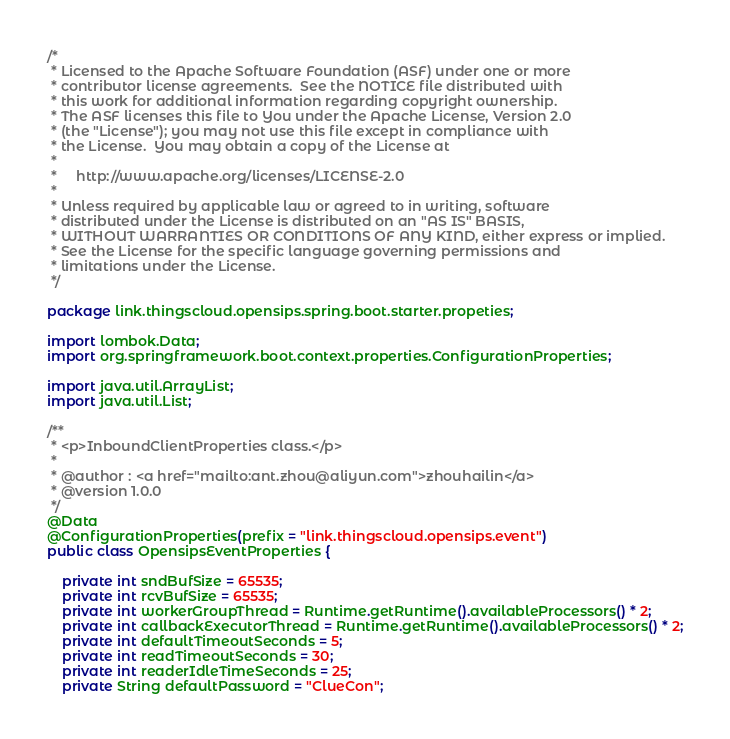Convert code to text. <code><loc_0><loc_0><loc_500><loc_500><_Java_>/*
 * Licensed to the Apache Software Foundation (ASF) under one or more
 * contributor license agreements.  See the NOTICE file distributed with
 * this work for additional information regarding copyright ownership.
 * The ASF licenses this file to You under the Apache License, Version 2.0
 * (the "License"); you may not use this file except in compliance with
 * the License.  You may obtain a copy of the License at
 *
 *     http://www.apache.org/licenses/LICENSE-2.0
 *
 * Unless required by applicable law or agreed to in writing, software
 * distributed under the License is distributed on an "AS IS" BASIS,
 * WITHOUT WARRANTIES OR CONDITIONS OF ANY KIND, either express or implied.
 * See the License for the specific language governing permissions and
 * limitations under the License.
 */

package link.thingscloud.opensips.spring.boot.starter.propeties;

import lombok.Data;
import org.springframework.boot.context.properties.ConfigurationProperties;

import java.util.ArrayList;
import java.util.List;

/**
 * <p>InboundClientProperties class.</p>
 *
 * @author : <a href="mailto:ant.zhou@aliyun.com">zhouhailin</a>
 * @version 1.0.0
 */
@Data
@ConfigurationProperties(prefix = "link.thingscloud.opensips.event")
public class OpensipsEventProperties {

    private int sndBufSize = 65535;
    private int rcvBufSize = 65535;
    private int workerGroupThread = Runtime.getRuntime().availableProcessors() * 2;
    private int callbackExecutorThread = Runtime.getRuntime().availableProcessors() * 2;
    private int defaultTimeoutSeconds = 5;
    private int readTimeoutSeconds = 30;
    private int readerIdleTimeSeconds = 25;
    private String defaultPassword = "ClueCon";</code> 